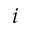Convert formula to latex. <formula><loc_0><loc_0><loc_500><loc_500>i</formula> 